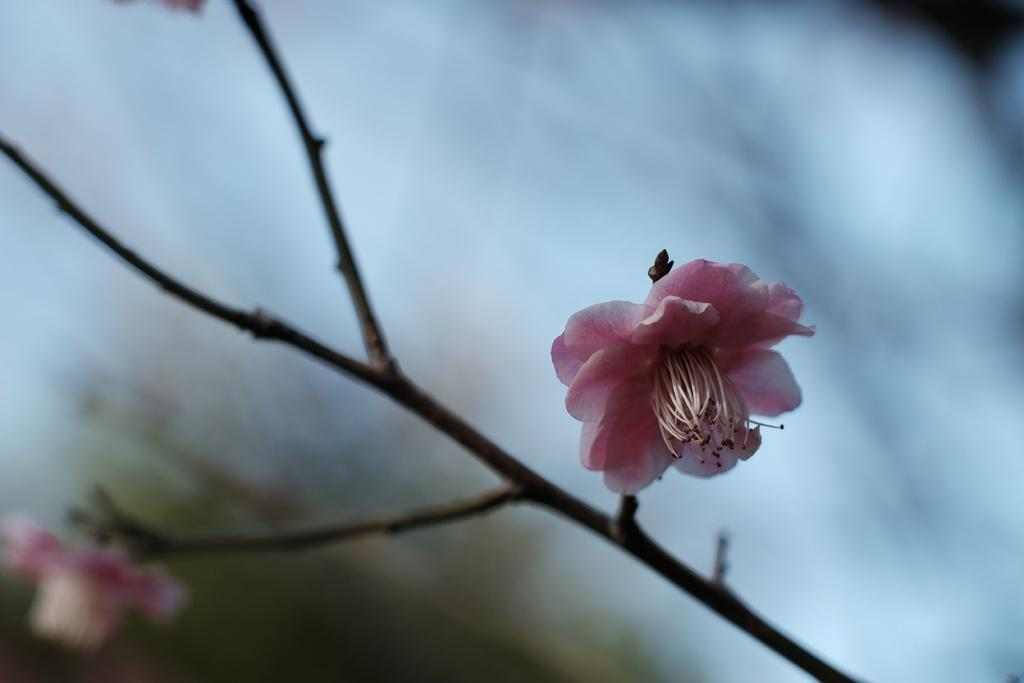What type of plants can be seen in the image? There are flowers in the image. What part of the flowers is visible in the image? There are stems in the image. Can you describe the background of the image? The background of the image is blurry. How many birds are sitting on the table in the image? There are no birds or tables present in the image. What type of creature can be seen interacting with the flowers in the image? There is no creature interacting with the flowers in the image; only the flowers and stems are present. 